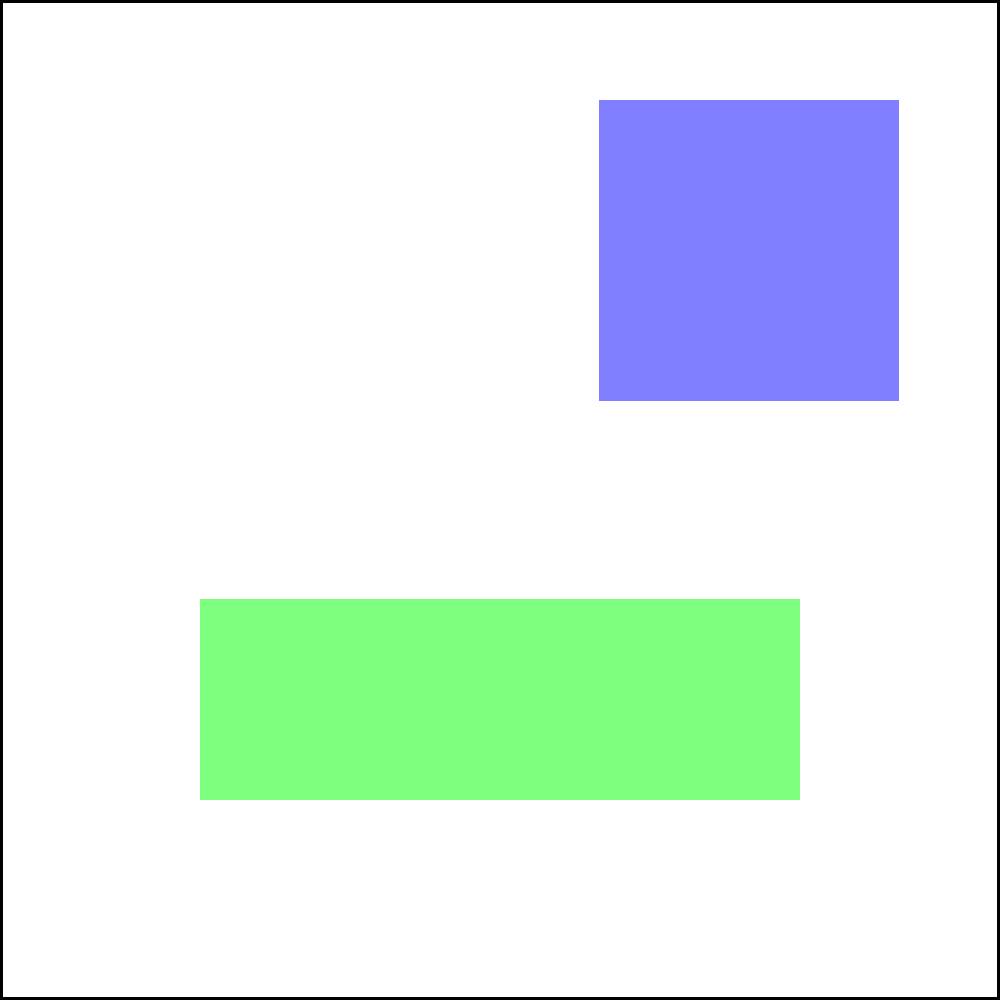Given the map above showing various geographical features and resource distribution points (A, B, C, and D), which resource location would be most strategic to control in order to maximize influence over the entire map while minimizing vulnerability? To determine the most strategic resource location, we need to consider several factors:

1. Proximity to geographical features:
   - A: Near the forest
   - B: Near the forest
   - C: Near the lake
   - D: Near the mountain

2. Centrality and access:
   - A: South-west corner, limited access
   - B: South-east corner, access to forest and open terrain
   - C: North-east corner, access to lake and open terrain
   - D: North-west corner, access to mountain and open terrain

3. Defensibility:
   - A: Partially protected by forest
   - B: Exposed, but with forest nearby for cover
   - C: Partially protected by lake
   - D: Protected by mountain

4. Resource control:
   - B offers control over the forest resources and access to the southern region
   - C provides control over the lake and its resources

5. Strategic positioning:
   - B allows for expansion towards the center and north
   - C allows for expansion towards the center and west

Considering these factors, location B emerges as the most strategic choice:

1. It provides access to forest resources.
2. It has a central-southern position, allowing for expansion in multiple directions.
3. While somewhat exposed, it has nearby forest cover for defensive maneuvers.
4. It offers the best balance of resource control, strategic positioning, and potential for map dominance.

Location C is a close second, but B's proximity to the forest and more central position gives it a slight edge in terms of overall strategic value.
Answer: B 